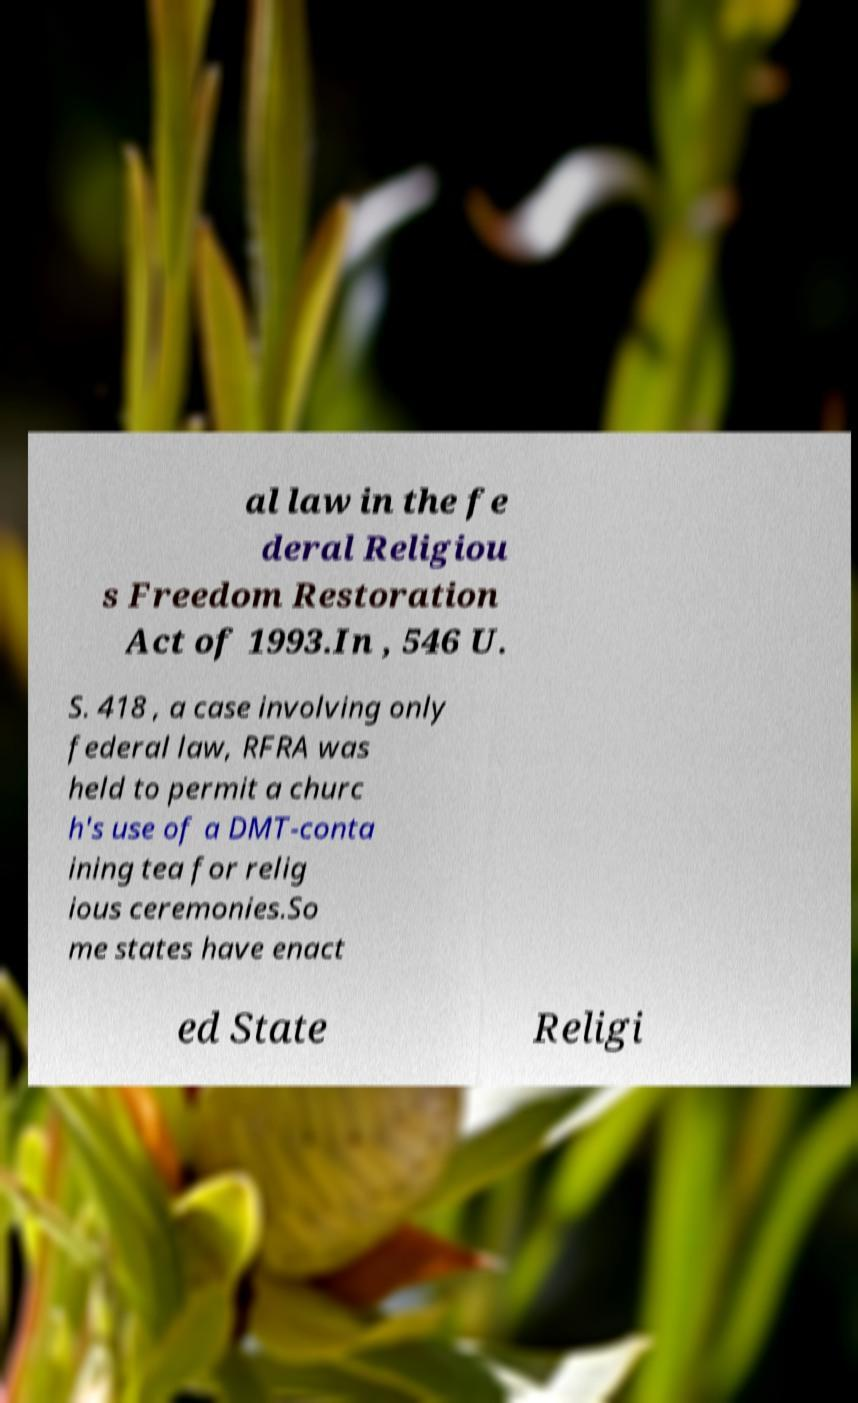There's text embedded in this image that I need extracted. Can you transcribe it verbatim? al law in the fe deral Religiou s Freedom Restoration Act of 1993.In , 546 U. S. 418 , a case involving only federal law, RFRA was held to permit a churc h's use of a DMT-conta ining tea for relig ious ceremonies.So me states have enact ed State Religi 